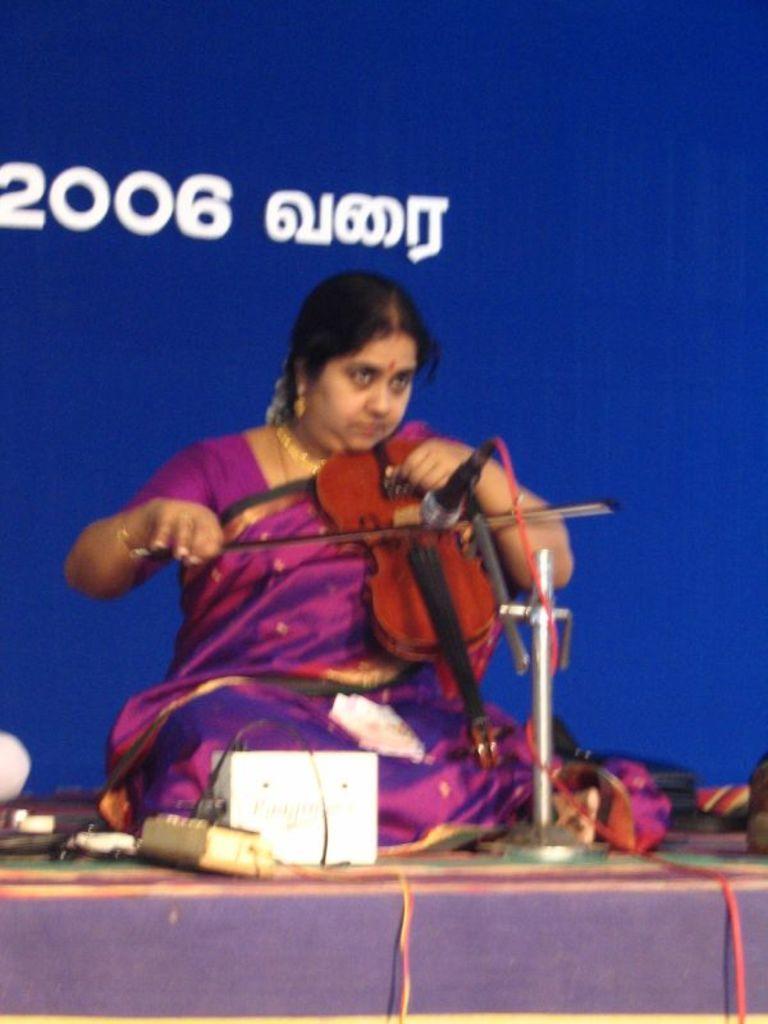Please provide a concise description of this image. In the image there is a woman playing violin and there is a mic and other objects in front of her. Behind the woman there is some banner. 